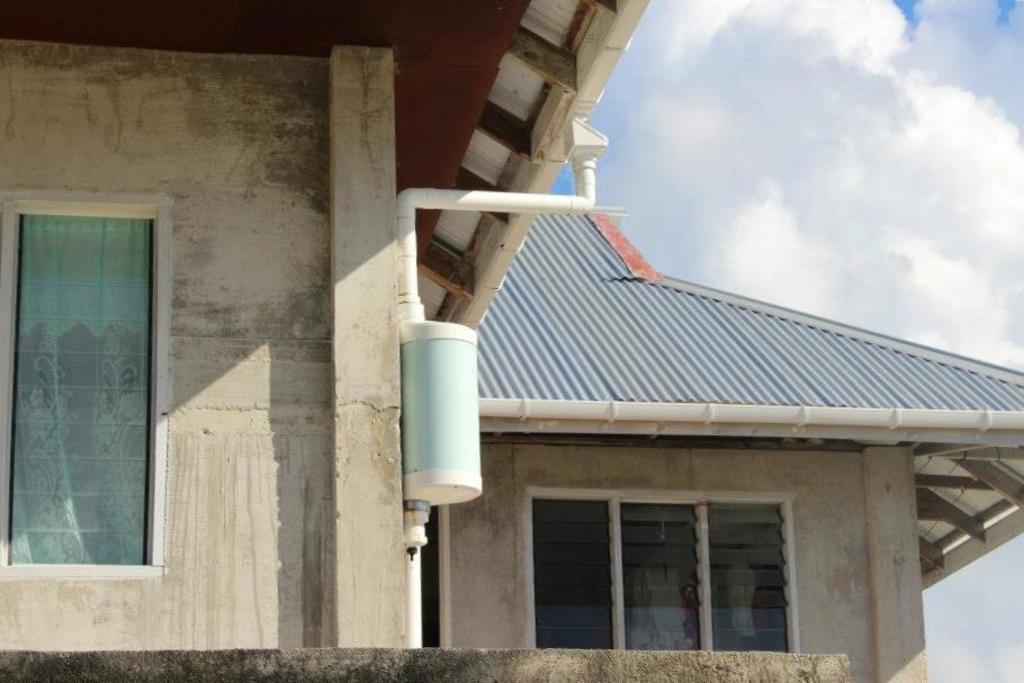Can you describe this image briefly? In this image I can see a house, windows and the sky. This image is taken may be during a day. 